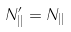<formula> <loc_0><loc_0><loc_500><loc_500>N _ { | | } ^ { \prime } = N _ { | | }</formula> 